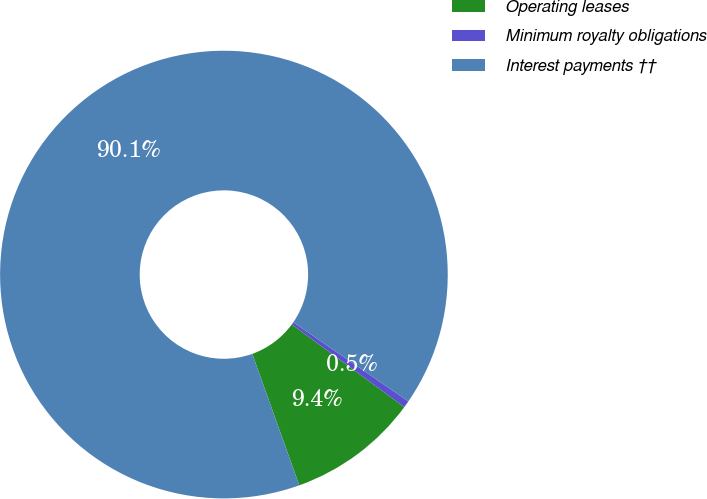<chart> <loc_0><loc_0><loc_500><loc_500><pie_chart><fcel>Operating leases<fcel>Minimum royalty obligations<fcel>Interest payments ††<nl><fcel>9.45%<fcel>0.5%<fcel>90.05%<nl></chart> 